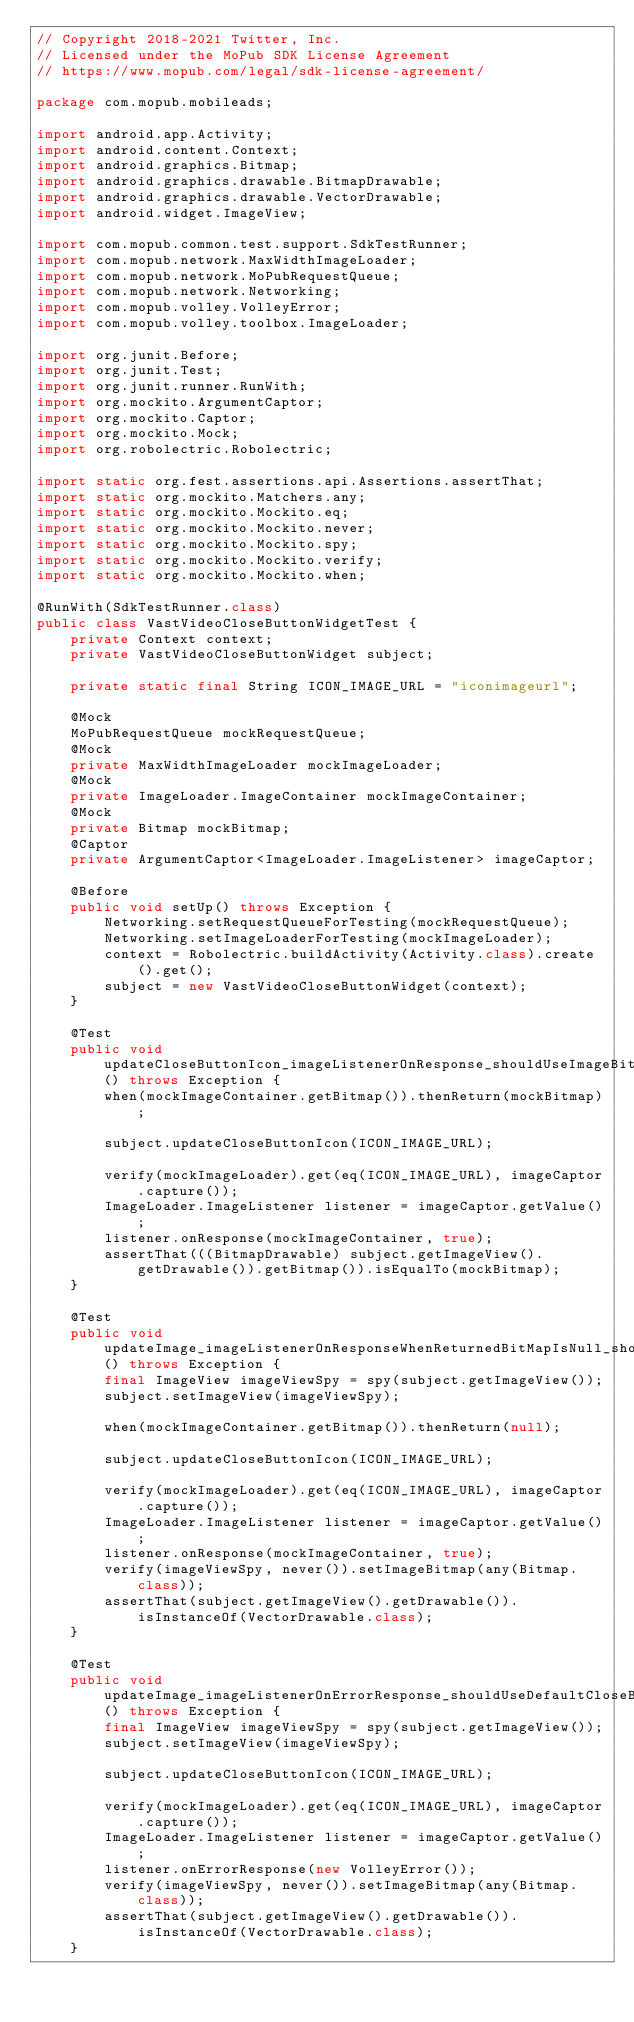Convert code to text. <code><loc_0><loc_0><loc_500><loc_500><_Java_>// Copyright 2018-2021 Twitter, Inc.
// Licensed under the MoPub SDK License Agreement
// https://www.mopub.com/legal/sdk-license-agreement/

package com.mopub.mobileads;

import android.app.Activity;
import android.content.Context;
import android.graphics.Bitmap;
import android.graphics.drawable.BitmapDrawable;
import android.graphics.drawable.VectorDrawable;
import android.widget.ImageView;

import com.mopub.common.test.support.SdkTestRunner;
import com.mopub.network.MaxWidthImageLoader;
import com.mopub.network.MoPubRequestQueue;
import com.mopub.network.Networking;
import com.mopub.volley.VolleyError;
import com.mopub.volley.toolbox.ImageLoader;

import org.junit.Before;
import org.junit.Test;
import org.junit.runner.RunWith;
import org.mockito.ArgumentCaptor;
import org.mockito.Captor;
import org.mockito.Mock;
import org.robolectric.Robolectric;

import static org.fest.assertions.api.Assertions.assertThat;
import static org.mockito.Matchers.any;
import static org.mockito.Mockito.eq;
import static org.mockito.Mockito.never;
import static org.mockito.Mockito.spy;
import static org.mockito.Mockito.verify;
import static org.mockito.Mockito.when;

@RunWith(SdkTestRunner.class)
public class VastVideoCloseButtonWidgetTest {
    private Context context;
    private VastVideoCloseButtonWidget subject;

    private static final String ICON_IMAGE_URL = "iconimageurl";

    @Mock
    MoPubRequestQueue mockRequestQueue;
    @Mock
    private MaxWidthImageLoader mockImageLoader;
    @Mock
    private ImageLoader.ImageContainer mockImageContainer;
    @Mock
    private Bitmap mockBitmap;
    @Captor
    private ArgumentCaptor<ImageLoader.ImageListener> imageCaptor;

    @Before
    public void setUp() throws Exception {
        Networking.setRequestQueueForTesting(mockRequestQueue);
        Networking.setImageLoaderForTesting(mockImageLoader);
        context = Robolectric.buildActivity(Activity.class).create().get();
        subject = new VastVideoCloseButtonWidget(context);
    }

    @Test
    public void updateCloseButtonIcon_imageListenerOnResponse_shouldUseImageBitmap() throws Exception {
        when(mockImageContainer.getBitmap()).thenReturn(mockBitmap);

        subject.updateCloseButtonIcon(ICON_IMAGE_URL);

        verify(mockImageLoader).get(eq(ICON_IMAGE_URL), imageCaptor.capture());
        ImageLoader.ImageListener listener = imageCaptor.getValue();
        listener.onResponse(mockImageContainer, true);
        assertThat(((BitmapDrawable) subject.getImageView().getDrawable()).getBitmap()).isEqualTo(mockBitmap);
    }

    @Test
    public void updateImage_imageListenerOnResponseWhenReturnedBitMapIsNull_shouldUseDefaultCloseButtonDrawable() throws Exception {
        final ImageView imageViewSpy = spy(subject.getImageView());
        subject.setImageView(imageViewSpy);

        when(mockImageContainer.getBitmap()).thenReturn(null);

        subject.updateCloseButtonIcon(ICON_IMAGE_URL);

        verify(mockImageLoader).get(eq(ICON_IMAGE_URL), imageCaptor.capture());
        ImageLoader.ImageListener listener = imageCaptor.getValue();
        listener.onResponse(mockImageContainer, true);
        verify(imageViewSpy, never()).setImageBitmap(any(Bitmap.class));
        assertThat(subject.getImageView().getDrawable()).isInstanceOf(VectorDrawable.class);
    }

    @Test
    public void updateImage_imageListenerOnErrorResponse_shouldUseDefaultCloseButtonDrawable() throws Exception {
        final ImageView imageViewSpy = spy(subject.getImageView());
        subject.setImageView(imageViewSpy);

        subject.updateCloseButtonIcon(ICON_IMAGE_URL);

        verify(mockImageLoader).get(eq(ICON_IMAGE_URL), imageCaptor.capture());
        ImageLoader.ImageListener listener = imageCaptor.getValue();
        listener.onErrorResponse(new VolleyError());
        verify(imageViewSpy, never()).setImageBitmap(any(Bitmap.class));
        assertThat(subject.getImageView().getDrawable()).isInstanceOf(VectorDrawable.class);
    }</code> 